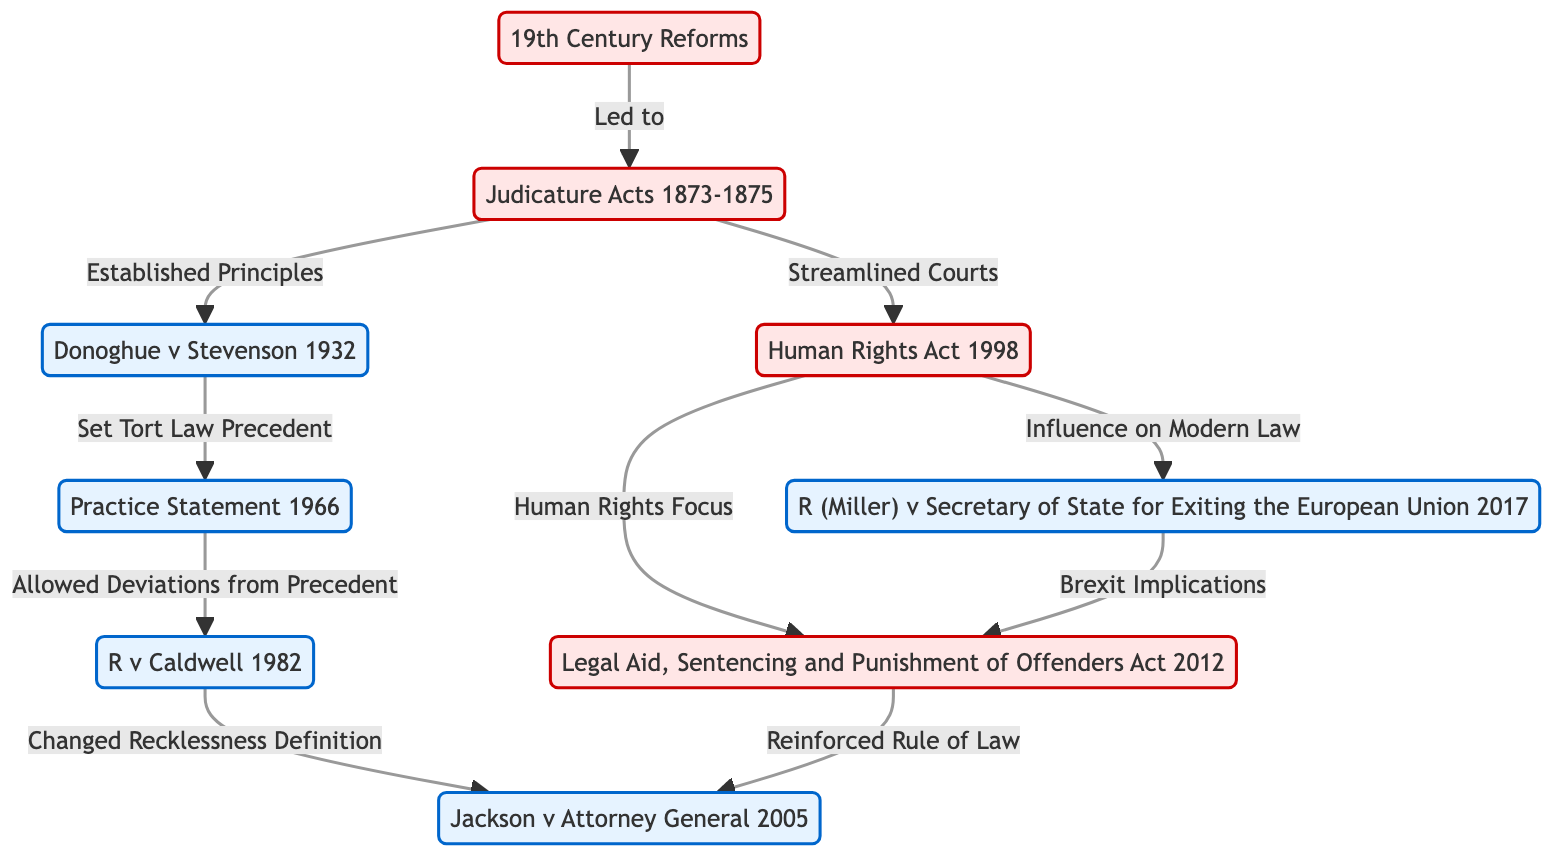What significant legal act was established in 1873? The node labeled "1873" indicates that this year marks the implementation of the "Judicature Acts 1873-1875." Therefore, the significant legal act established is the "Judicature Acts."
Answer: Judicature Acts Which case set a precedent for tort law in 1898? The diagram shows a direct link from the node "1898" to "1966," and the label on the arrow states "Set Tort Law Precedent." The case that established this precedent is "Donoghue v Stevenson."
Answer: Donoghue v Stevenson How many landmark cases are depicted in the diagram? The diagram lists five landmark cases categorized under the class "landmark," which includes 1898, 1966, 1971, 1984, and 2016. Counting these values gives the total number of landmark cases.
Answer: 5 Which act emphasizes a human rights focus leading to the 2013 legal transformations? From the diagram, there is a link from the node "1950," labeled "Human Rights Focus," that leads to "2013." Thus, the act emphasizing this focus is the "Human Rights Act."
Answer: Human Rights Act What landmark case allowed deviations from precedent in 1966? The flowchart provides a direct connection from the "1966" node, indicating it is connected to the concept of allowing deviations from precedent. The case associated with it is the "Practice Statement."
Answer: Practice Statement Which two key events are linked to the year 1984? In the diagram, there is an outgoing connection from "1984" labeled "Reinforced Rule of Law" that points back to "2013," as well as an incoming connection from "1971" indicating that it is an outcome of changes to recklessness definitions. These connections thus identify the two key events associated with 1984: "R v Caldwell" and "Legal Aid Act."
Answer: R v Caldwell and Legal Aid Act What was a leading outcome of the 19th Century Reforms? The node "1800," marked as "19th Century Reforms," leads to "1873" with an annotation "Led to." This indicates that a leading outcome of the 19th Century reforms was the creation of the Judicature Acts.
Answer: Judicature Acts Which case was addressed in 2016, concerning Brexit implications? The diagram indicates a direct relationship from the "2016" node showing Brexit implications leading to "R (Miller) v Secretary of State for Exiting the European Union." This case explains the legal context associated with Brexit.
Answer: R (Miller) v Secretary of State for Exiting the European Union 